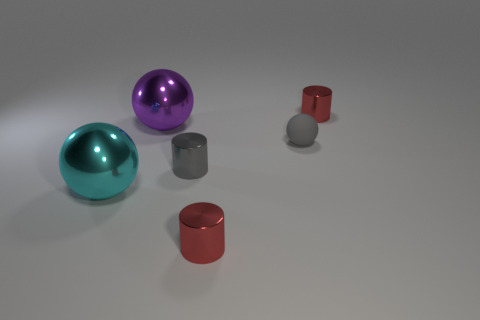Subtract all cyan metallic spheres. How many spheres are left? 2 Add 1 tiny purple metallic spheres. How many objects exist? 7 Subtract 3 cylinders. How many cylinders are left? 0 Subtract all purple spheres. How many spheres are left? 2 Subtract all red balls. How many red cylinders are left? 2 Add 5 tiny gray matte balls. How many tiny gray matte balls exist? 6 Subtract 0 green cylinders. How many objects are left? 6 Subtract all gray spheres. Subtract all gray cylinders. How many spheres are left? 2 Subtract all purple metallic things. Subtract all small rubber spheres. How many objects are left? 4 Add 4 big shiny things. How many big shiny things are left? 6 